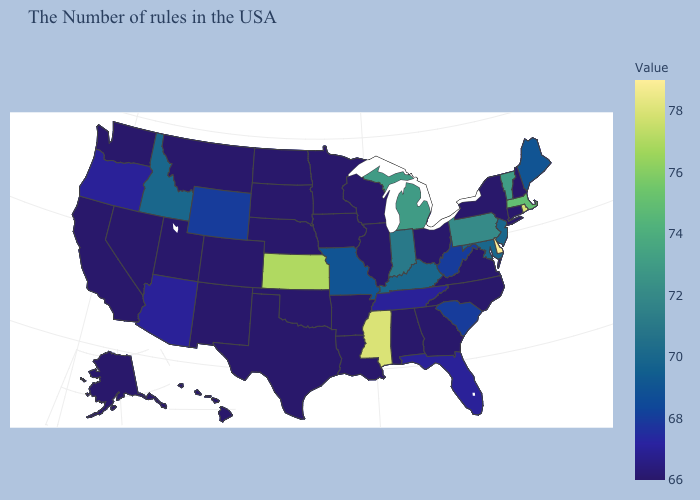Which states have the lowest value in the South?
Give a very brief answer. Virginia, North Carolina, Georgia, Alabama, Louisiana, Arkansas, Oklahoma, Texas. Which states have the lowest value in the USA?
Write a very short answer. New Hampshire, Connecticut, New York, Virginia, North Carolina, Ohio, Georgia, Alabama, Wisconsin, Illinois, Louisiana, Arkansas, Minnesota, Iowa, Nebraska, Oklahoma, Texas, South Dakota, North Dakota, Colorado, New Mexico, Utah, Montana, Nevada, California, Washington, Alaska, Hawaii. Does the map have missing data?
Be succinct. No. Does the map have missing data?
Keep it brief. No. Does Arkansas have the lowest value in the South?
Keep it brief. Yes. Does Oregon have the lowest value in the West?
Concise answer only. No. 